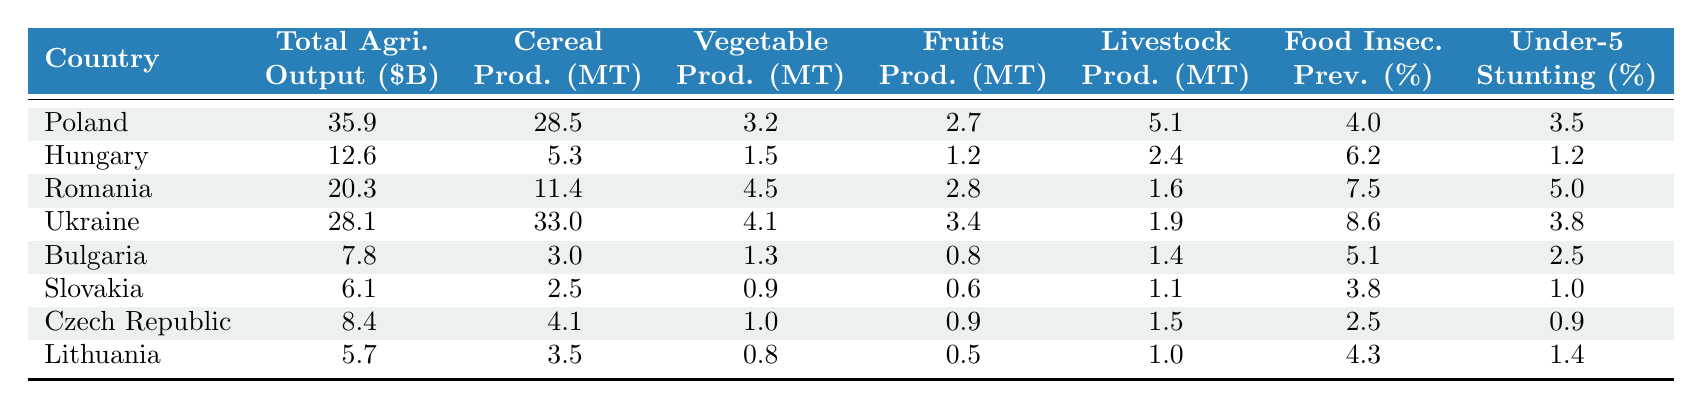What is the total agricultural output in billions for Romania? The table shows that Romania's total agricultural output is listed as 20.3 billion dollars.
Answer: 20.3 Which country has the highest cereal production? According to the table, Ukraine has the highest cereal production with 33.0 metric tons.
Answer: Ukraine What is the food insecurity prevalence percentage for Hungary? The table indicates that Hungary's food insecurity prevalence is 6.2%.
Answer: 6.2 What is the difference in total agricultural output between Poland and Bulgaria? Poland has a total agricultural output of 35.9 billion dollars and Bulgaria has 7.8 billion dollars. The difference is 35.9 - 7.8 = 28.1 billion dollars.
Answer: 28.1 Which country has the highest percentage of under-five stunting prevalence? Romania has the highest percentage of under-five stunting prevalence at 5.0%.
Answer: Romania What country has both the lowest food insecurity prevalence and under-five stunting prevalence? Slovakia has the lowest food insecurity prevalence at 3.8% and under-five stunting prevalence at 1.0%.
Answer: Slovakia Calculate the average food insecurity prevalence for all countries listed. The food insecurity prevalence percentages are: 4.0, 6.2, 7.5, 8.6, 5.1, 3.8, 2.5, and 4.3. Summing these gives 4.0 + 6.2 + 7.5 + 8.6 + 5.1 + 3.8 + 2.5 + 4.3 = 42.0, and there are 8 countries. Dividing gives an average of 42.0 / 8 = 5.25%.
Answer: 5.25 Is there any country with a total agricultural output below 10 billion dollars? Yes, both Bulgaria (7.8 billion) and Slovakia (6.1 billion) have total agricultural outputs below 10 billion dollars.
Answer: Yes Identify the country with the second lowest vegetable production. Vegetable production for the countries is: Poland (3.2 MT), Hungary (1.5 MT), Romania (4.5 MT), Ukraine (4.1 MT), Bulgaria (1.3 MT), Slovakia (0.9 MT), Czech Republic (1.0 MT), and Lithuania (0.8 MT). Slovakia has the lowest at 0.9 MT and Hungary has the second lowest at 1.5 MT.
Answer: Hungary What is the combined livestock production for Poland and Ukraine? Poland has livestock production of 5.1 MT and Ukraine has 1.9 MT. Adding these together gives 5.1 + 1.9 = 7.0 MT.
Answer: 7.0 